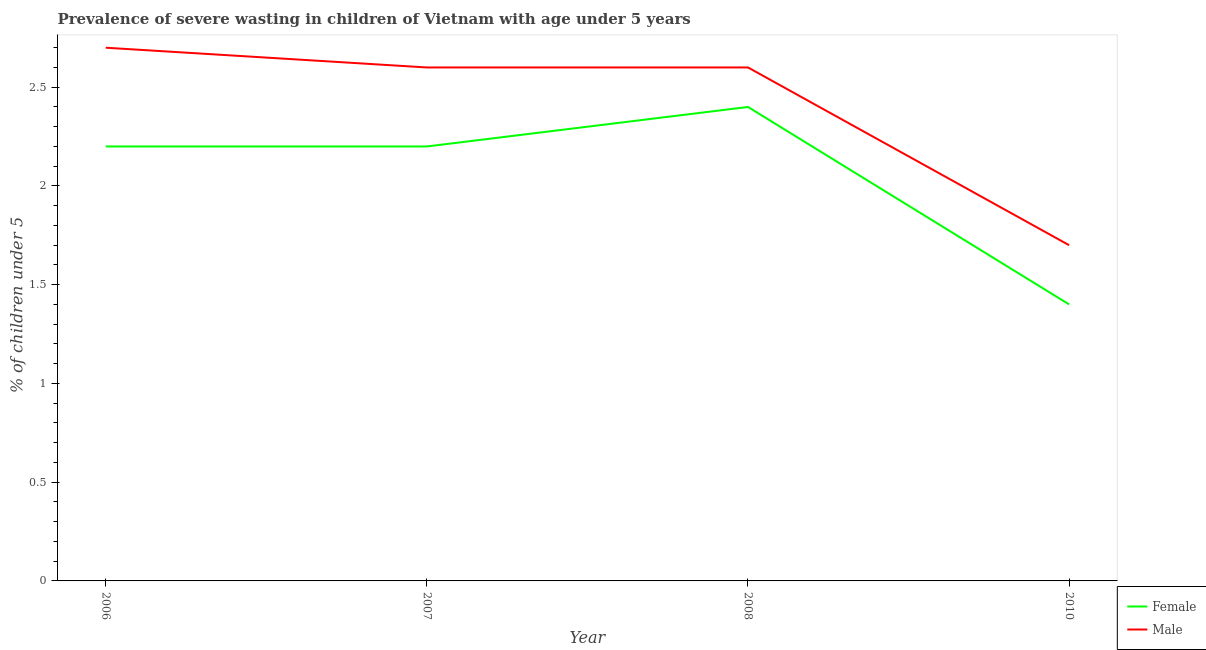How many different coloured lines are there?
Your answer should be compact. 2. What is the percentage of undernourished female children in 2006?
Keep it short and to the point. 2.2. Across all years, what is the maximum percentage of undernourished female children?
Your answer should be compact. 2.4. Across all years, what is the minimum percentage of undernourished male children?
Your response must be concise. 1.7. In which year was the percentage of undernourished male children maximum?
Give a very brief answer. 2006. What is the total percentage of undernourished female children in the graph?
Make the answer very short. 8.2. What is the difference between the percentage of undernourished male children in 2006 and that in 2007?
Ensure brevity in your answer.  0.1. What is the difference between the percentage of undernourished female children in 2006 and the percentage of undernourished male children in 2008?
Ensure brevity in your answer.  -0.4. What is the average percentage of undernourished male children per year?
Provide a succinct answer. 2.4. In the year 2007, what is the difference between the percentage of undernourished female children and percentage of undernourished male children?
Give a very brief answer. -0.4. What is the ratio of the percentage of undernourished male children in 2006 to that in 2008?
Offer a terse response. 1.04. Is the percentage of undernourished male children in 2006 less than that in 2008?
Ensure brevity in your answer.  No. What is the difference between the highest and the second highest percentage of undernourished female children?
Keep it short and to the point. 0.2. What is the difference between the highest and the lowest percentage of undernourished male children?
Offer a terse response. 1. In how many years, is the percentage of undernourished female children greater than the average percentage of undernourished female children taken over all years?
Ensure brevity in your answer.  3. Is the sum of the percentage of undernourished female children in 2007 and 2010 greater than the maximum percentage of undernourished male children across all years?
Offer a very short reply. Yes. Is the percentage of undernourished female children strictly greater than the percentage of undernourished male children over the years?
Offer a very short reply. No. How many years are there in the graph?
Give a very brief answer. 4. How are the legend labels stacked?
Your answer should be very brief. Vertical. What is the title of the graph?
Keep it short and to the point. Prevalence of severe wasting in children of Vietnam with age under 5 years. Does "Services" appear as one of the legend labels in the graph?
Offer a terse response. No. What is the label or title of the X-axis?
Keep it short and to the point. Year. What is the label or title of the Y-axis?
Keep it short and to the point.  % of children under 5. What is the  % of children under 5 of Female in 2006?
Give a very brief answer. 2.2. What is the  % of children under 5 in Male in 2006?
Your response must be concise. 2.7. What is the  % of children under 5 of Female in 2007?
Ensure brevity in your answer.  2.2. What is the  % of children under 5 in Male in 2007?
Your answer should be very brief. 2.6. What is the  % of children under 5 of Female in 2008?
Your answer should be compact. 2.4. What is the  % of children under 5 of Male in 2008?
Offer a very short reply. 2.6. What is the  % of children under 5 of Female in 2010?
Offer a terse response. 1.4. What is the  % of children under 5 of Male in 2010?
Your response must be concise. 1.7. Across all years, what is the maximum  % of children under 5 of Female?
Offer a very short reply. 2.4. Across all years, what is the maximum  % of children under 5 in Male?
Your answer should be compact. 2.7. Across all years, what is the minimum  % of children under 5 of Female?
Your response must be concise. 1.4. Across all years, what is the minimum  % of children under 5 of Male?
Provide a short and direct response. 1.7. What is the difference between the  % of children under 5 in Female in 2006 and that in 2007?
Your response must be concise. 0. What is the difference between the  % of children under 5 in Female in 2006 and that in 2008?
Your response must be concise. -0.2. What is the difference between the  % of children under 5 in Male in 2006 and that in 2010?
Make the answer very short. 1. What is the difference between the  % of children under 5 of Female in 2006 and the  % of children under 5 of Male in 2010?
Keep it short and to the point. 0.5. What is the difference between the  % of children under 5 in Female in 2007 and the  % of children under 5 in Male in 2008?
Your answer should be compact. -0.4. What is the average  % of children under 5 of Female per year?
Your response must be concise. 2.05. What is the average  % of children under 5 in Male per year?
Your answer should be very brief. 2.4. In the year 2007, what is the difference between the  % of children under 5 of Female and  % of children under 5 of Male?
Provide a short and direct response. -0.4. In the year 2008, what is the difference between the  % of children under 5 in Female and  % of children under 5 in Male?
Your answer should be compact. -0.2. What is the ratio of the  % of children under 5 of Female in 2006 to that in 2007?
Your answer should be very brief. 1. What is the ratio of the  % of children under 5 in Male in 2006 to that in 2008?
Make the answer very short. 1.04. What is the ratio of the  % of children under 5 in Female in 2006 to that in 2010?
Give a very brief answer. 1.57. What is the ratio of the  % of children under 5 in Male in 2006 to that in 2010?
Offer a terse response. 1.59. What is the ratio of the  % of children under 5 of Male in 2007 to that in 2008?
Your answer should be very brief. 1. What is the ratio of the  % of children under 5 of Female in 2007 to that in 2010?
Your response must be concise. 1.57. What is the ratio of the  % of children under 5 of Male in 2007 to that in 2010?
Give a very brief answer. 1.53. What is the ratio of the  % of children under 5 in Female in 2008 to that in 2010?
Your answer should be very brief. 1.71. What is the ratio of the  % of children under 5 in Male in 2008 to that in 2010?
Provide a succinct answer. 1.53. What is the difference between the highest and the second highest  % of children under 5 in Female?
Your answer should be very brief. 0.2. 